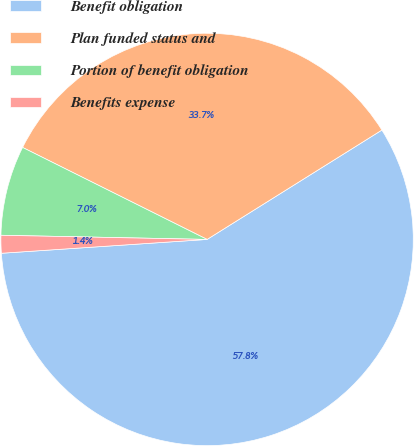Convert chart. <chart><loc_0><loc_0><loc_500><loc_500><pie_chart><fcel>Benefit obligation<fcel>Plan funded status and<fcel>Portion of benefit obligation<fcel>Benefits expense<nl><fcel>57.83%<fcel>33.74%<fcel>7.04%<fcel>1.39%<nl></chart> 